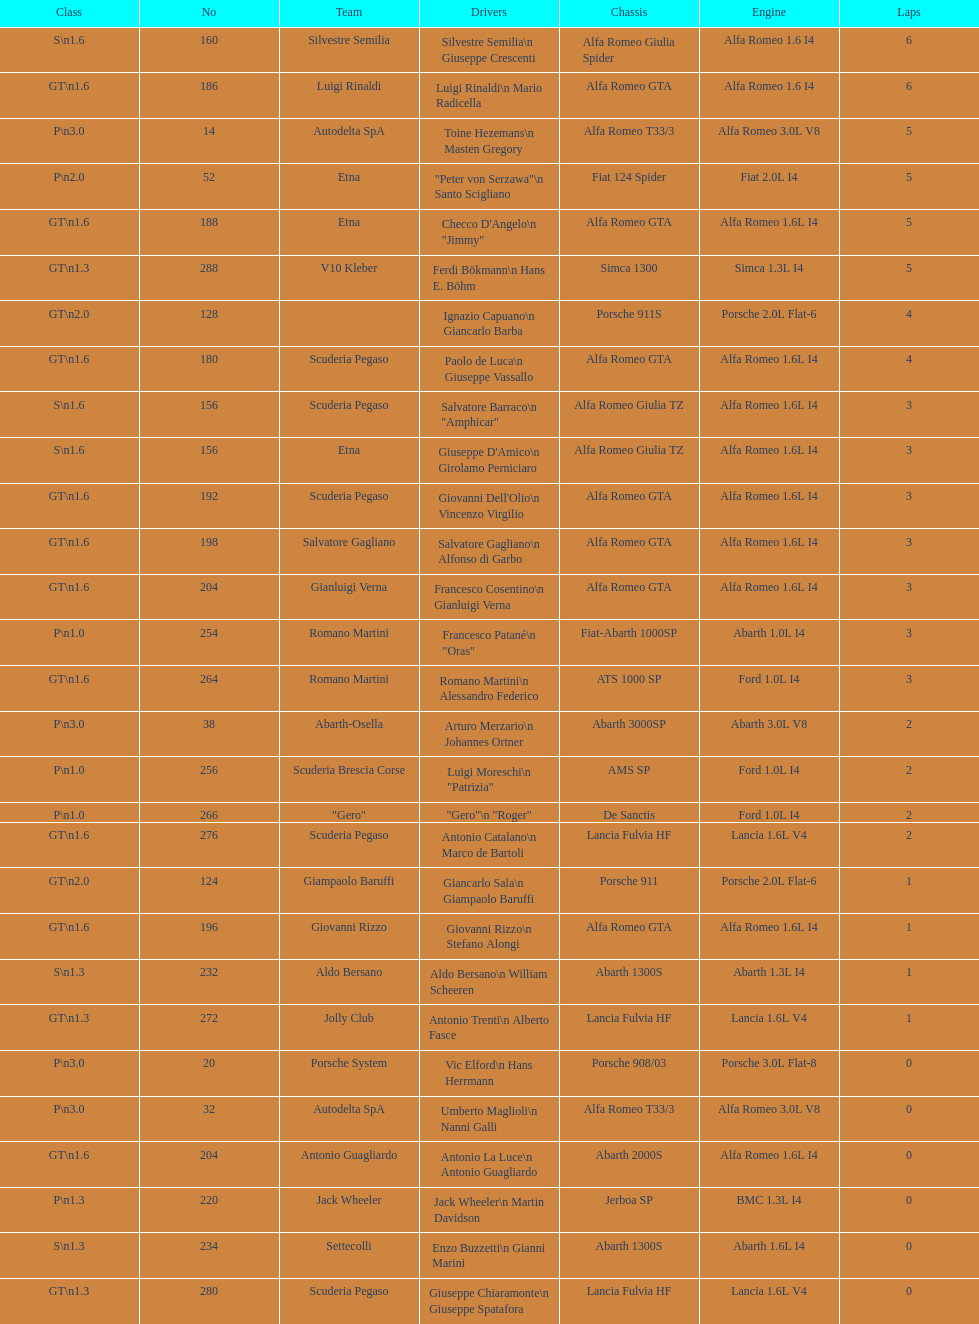Which frame is between simca 1300 and alfa romeo gta? Porsche 911S. 